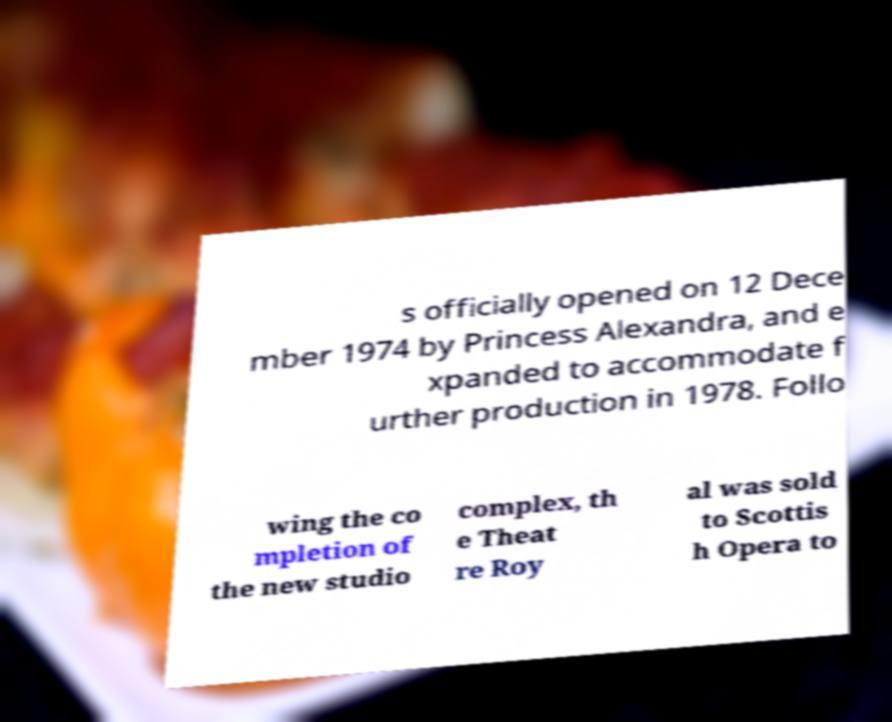Can you read and provide the text displayed in the image?This photo seems to have some interesting text. Can you extract and type it out for me? s officially opened on 12 Dece mber 1974 by Princess Alexandra, and e xpanded to accommodate f urther production in 1978. Follo wing the co mpletion of the new studio complex, th e Theat re Roy al was sold to Scottis h Opera to 